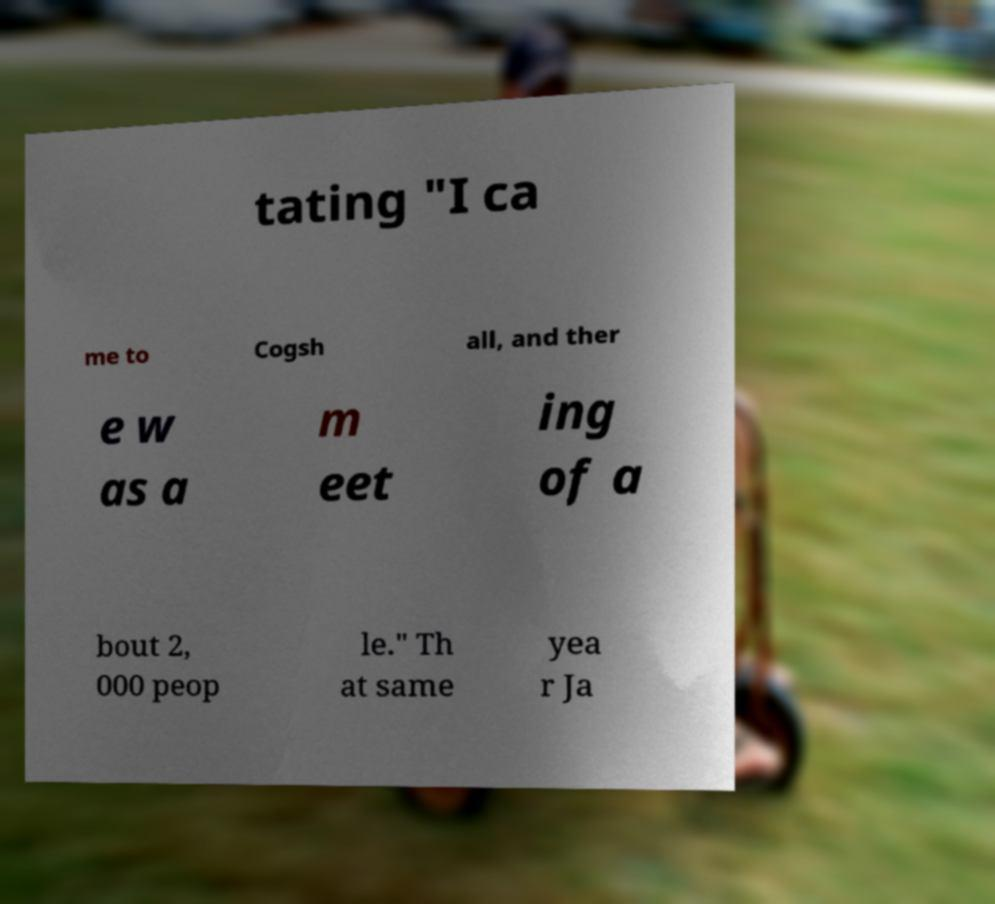What messages or text are displayed in this image? I need them in a readable, typed format. tating "I ca me to Cogsh all, and ther e w as a m eet ing of a bout 2, 000 peop le." Th at same yea r Ja 